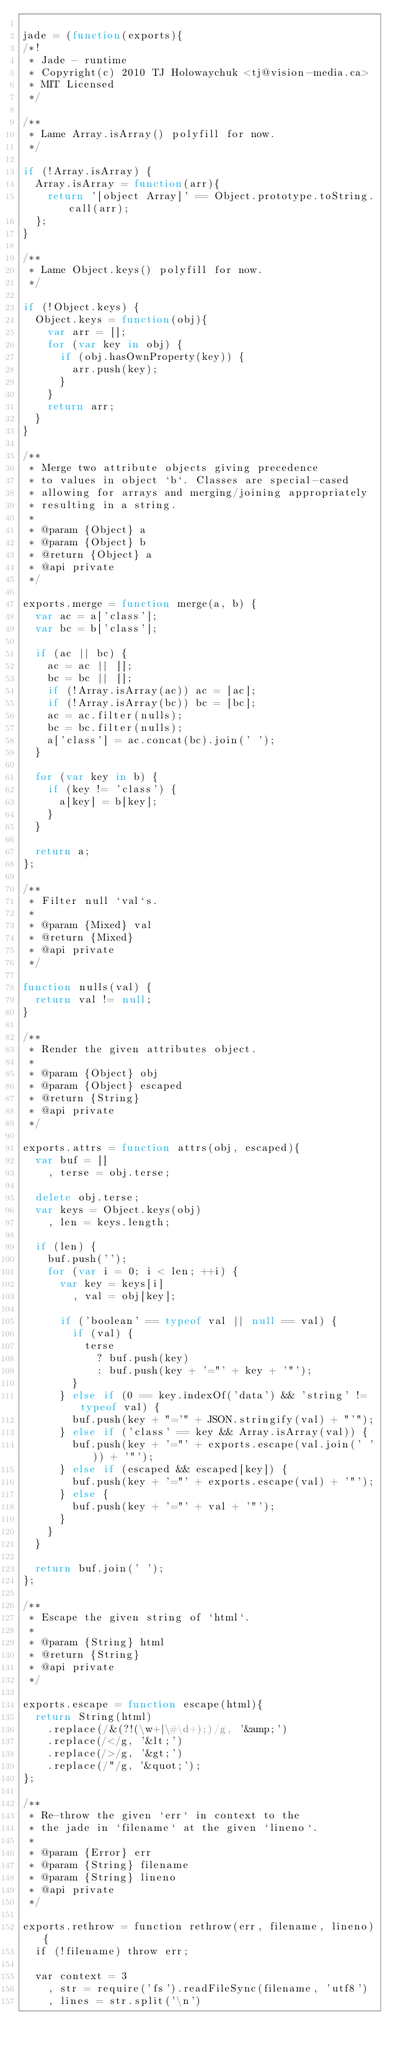<code> <loc_0><loc_0><loc_500><loc_500><_JavaScript_>
jade = (function(exports){
/*!
 * Jade - runtime
 * Copyright(c) 2010 TJ Holowaychuk <tj@vision-media.ca>
 * MIT Licensed
 */

/**
 * Lame Array.isArray() polyfill for now.
 */

if (!Array.isArray) {
  Array.isArray = function(arr){
    return '[object Array]' == Object.prototype.toString.call(arr);
  };
}

/**
 * Lame Object.keys() polyfill for now.
 */

if (!Object.keys) {
  Object.keys = function(obj){
    var arr = [];
    for (var key in obj) {
      if (obj.hasOwnProperty(key)) {
        arr.push(key);
      }
    }
    return arr;
  }
}

/**
 * Merge two attribute objects giving precedence
 * to values in object `b`. Classes are special-cased
 * allowing for arrays and merging/joining appropriately
 * resulting in a string.
 *
 * @param {Object} a
 * @param {Object} b
 * @return {Object} a
 * @api private
 */

exports.merge = function merge(a, b) {
  var ac = a['class'];
  var bc = b['class'];

  if (ac || bc) {
    ac = ac || [];
    bc = bc || [];
    if (!Array.isArray(ac)) ac = [ac];
    if (!Array.isArray(bc)) bc = [bc];
    ac = ac.filter(nulls);
    bc = bc.filter(nulls);
    a['class'] = ac.concat(bc).join(' ');
  }

  for (var key in b) {
    if (key != 'class') {
      a[key] = b[key];
    }
  }

  return a;
};

/**
 * Filter null `val`s.
 *
 * @param {Mixed} val
 * @return {Mixed}
 * @api private
 */

function nulls(val) {
  return val != null;
}

/**
 * Render the given attributes object.
 *
 * @param {Object} obj
 * @param {Object} escaped
 * @return {String}
 * @api private
 */

exports.attrs = function attrs(obj, escaped){
  var buf = []
    , terse = obj.terse;

  delete obj.terse;
  var keys = Object.keys(obj)
    , len = keys.length;

  if (len) {
    buf.push('');
    for (var i = 0; i < len; ++i) {
      var key = keys[i]
        , val = obj[key];

      if ('boolean' == typeof val || null == val) {
        if (val) {
          terse
            ? buf.push(key)
            : buf.push(key + '="' + key + '"');
        }
      } else if (0 == key.indexOf('data') && 'string' != typeof val) {
        buf.push(key + "='" + JSON.stringify(val) + "'");
      } else if ('class' == key && Array.isArray(val)) {
        buf.push(key + '="' + exports.escape(val.join(' ')) + '"');
      } else if (escaped && escaped[key]) {
        buf.push(key + '="' + exports.escape(val) + '"');
      } else {
        buf.push(key + '="' + val + '"');
      }
    }
  }

  return buf.join(' ');
};

/**
 * Escape the given string of `html`.
 *
 * @param {String} html
 * @return {String}
 * @api private
 */

exports.escape = function escape(html){
  return String(html)
    .replace(/&(?!(\w+|\#\d+);)/g, '&amp;')
    .replace(/</g, '&lt;')
    .replace(/>/g, '&gt;')
    .replace(/"/g, '&quot;');
};

/**
 * Re-throw the given `err` in context to the
 * the jade in `filename` at the given `lineno`.
 *
 * @param {Error} err
 * @param {String} filename
 * @param {String} lineno
 * @api private
 */

exports.rethrow = function rethrow(err, filename, lineno){
  if (!filename) throw err;

  var context = 3
    , str = require('fs').readFileSync(filename, 'utf8')
    , lines = str.split('\n')</code> 